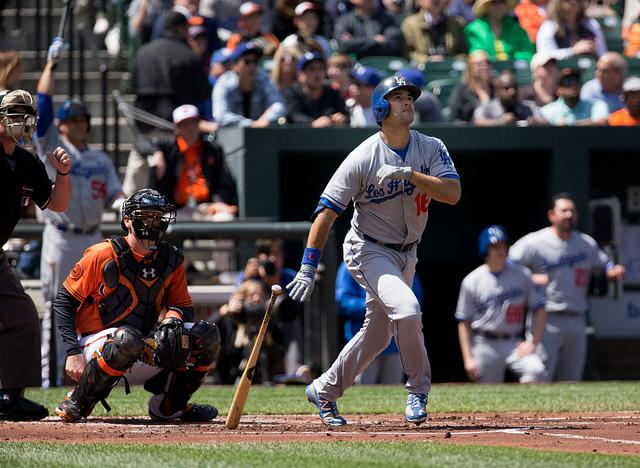The player just hit the ball so he watches it while he runs to what base? Please explain your reasoning. first. The first base to get to is the first one. 